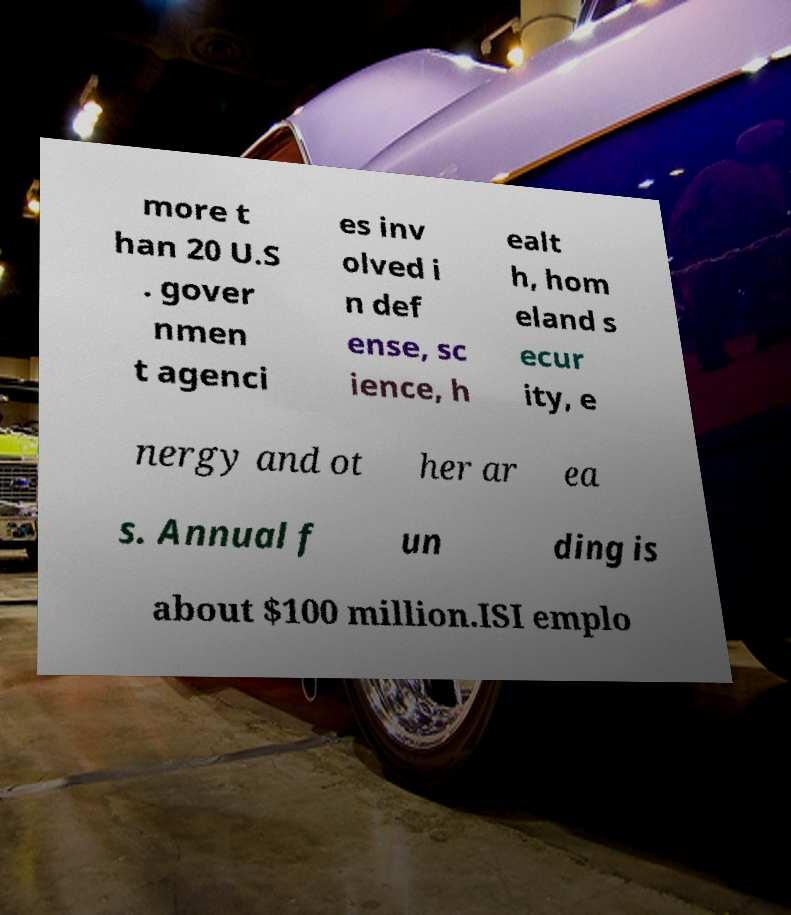Can you read and provide the text displayed in the image?This photo seems to have some interesting text. Can you extract and type it out for me? more t han 20 U.S . gover nmen t agenci es inv olved i n def ense, sc ience, h ealt h, hom eland s ecur ity, e nergy and ot her ar ea s. Annual f un ding is about $100 million.ISI emplo 